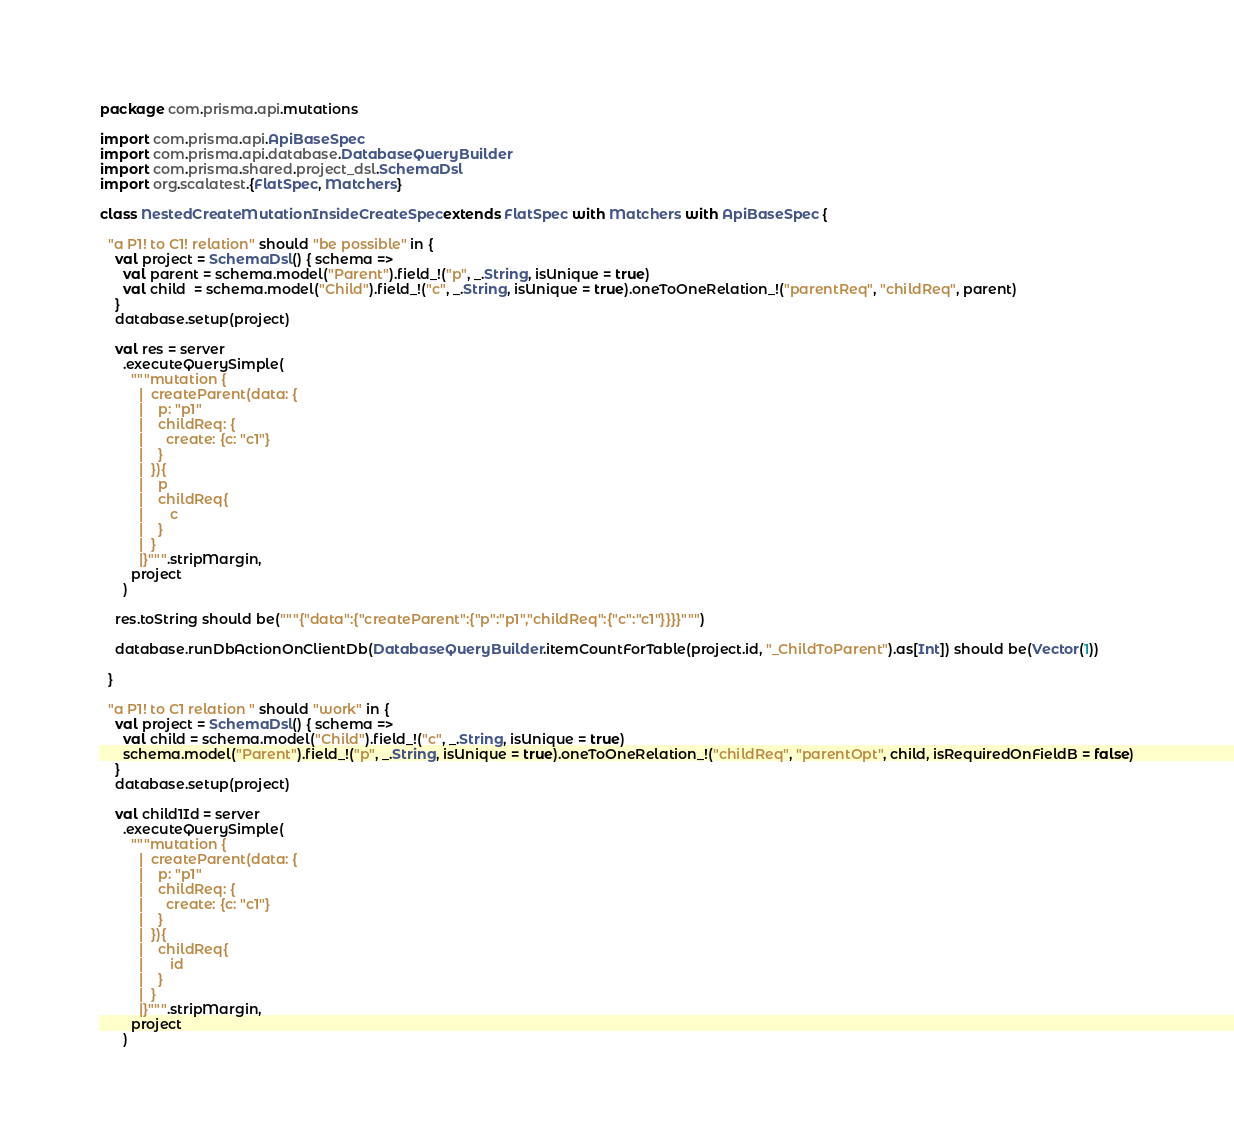Convert code to text. <code><loc_0><loc_0><loc_500><loc_500><_Scala_>package com.prisma.api.mutations

import com.prisma.api.ApiBaseSpec
import com.prisma.api.database.DatabaseQueryBuilder
import com.prisma.shared.project_dsl.SchemaDsl
import org.scalatest.{FlatSpec, Matchers}

class NestedCreateMutationInsideCreateSpec extends FlatSpec with Matchers with ApiBaseSpec {

  "a P1! to C1! relation" should "be possible" in {
    val project = SchemaDsl() { schema =>
      val parent = schema.model("Parent").field_!("p", _.String, isUnique = true)
      val child  = schema.model("Child").field_!("c", _.String, isUnique = true).oneToOneRelation_!("parentReq", "childReq", parent)
    }
    database.setup(project)

    val res = server
      .executeQuerySimple(
        """mutation {
          |  createParent(data: {
          |    p: "p1"
          |    childReq: {
          |      create: {c: "c1"}
          |    }
          |  }){
          |    p
          |    childReq{
          |       c
          |    }
          |  }
          |}""".stripMargin,
        project
      )

    res.toString should be("""{"data":{"createParent":{"p":"p1","childReq":{"c":"c1"}}}}""")

    database.runDbActionOnClientDb(DatabaseQueryBuilder.itemCountForTable(project.id, "_ChildToParent").as[Int]) should be(Vector(1))

  }

  "a P1! to C1 relation " should "work" in {
    val project = SchemaDsl() { schema =>
      val child = schema.model("Child").field_!("c", _.String, isUnique = true)
      schema.model("Parent").field_!("p", _.String, isUnique = true).oneToOneRelation_!("childReq", "parentOpt", child, isRequiredOnFieldB = false)
    }
    database.setup(project)

    val child1Id = server
      .executeQuerySimple(
        """mutation {
          |  createParent(data: {
          |    p: "p1"
          |    childReq: {
          |      create: {c: "c1"}
          |    }
          |  }){
          |    childReq{
          |       id
          |    }
          |  }
          |}""".stripMargin,
        project
      )</code> 